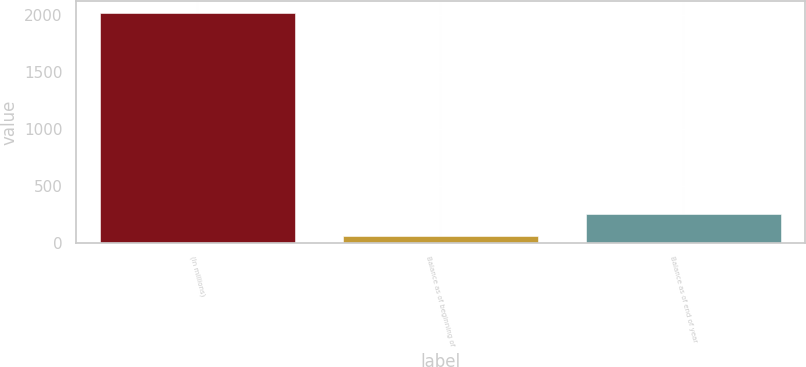<chart> <loc_0><loc_0><loc_500><loc_500><bar_chart><fcel>(In millions)<fcel>Balance as of beginning of<fcel>Balance as of end of year<nl><fcel>2014<fcel>57.3<fcel>252.97<nl></chart> 